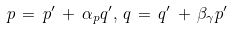Convert formula to latex. <formula><loc_0><loc_0><loc_500><loc_500>p \, = \, p ^ { \prime } \, + \, \alpha _ { p } q ^ { \prime } , \, q \, = \, q ^ { \prime } \, + \, \beta _ { \gamma } p ^ { \prime }</formula> 